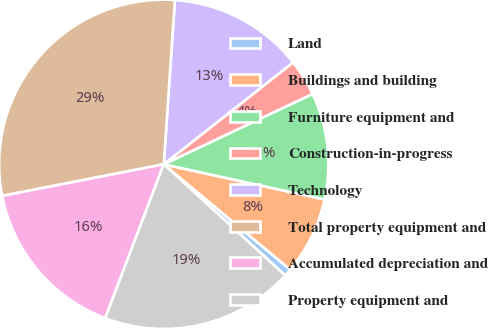Convert chart to OTSL. <chart><loc_0><loc_0><loc_500><loc_500><pie_chart><fcel>Land<fcel>Buildings and building<fcel>Furniture equipment and<fcel>Construction-in-progress<fcel>Technology<fcel>Total property equipment and<fcel>Accumulated depreciation and<fcel>Property equipment and<nl><fcel>0.75%<fcel>7.62%<fcel>10.46%<fcel>3.59%<fcel>13.3%<fcel>29.15%<fcel>16.14%<fcel>18.98%<nl></chart> 